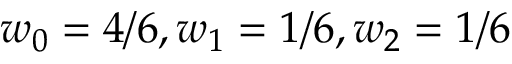<formula> <loc_0><loc_0><loc_500><loc_500>w _ { 0 } = 4 / 6 , w _ { 1 } = 1 / 6 , w _ { 2 } = 1 / 6</formula> 